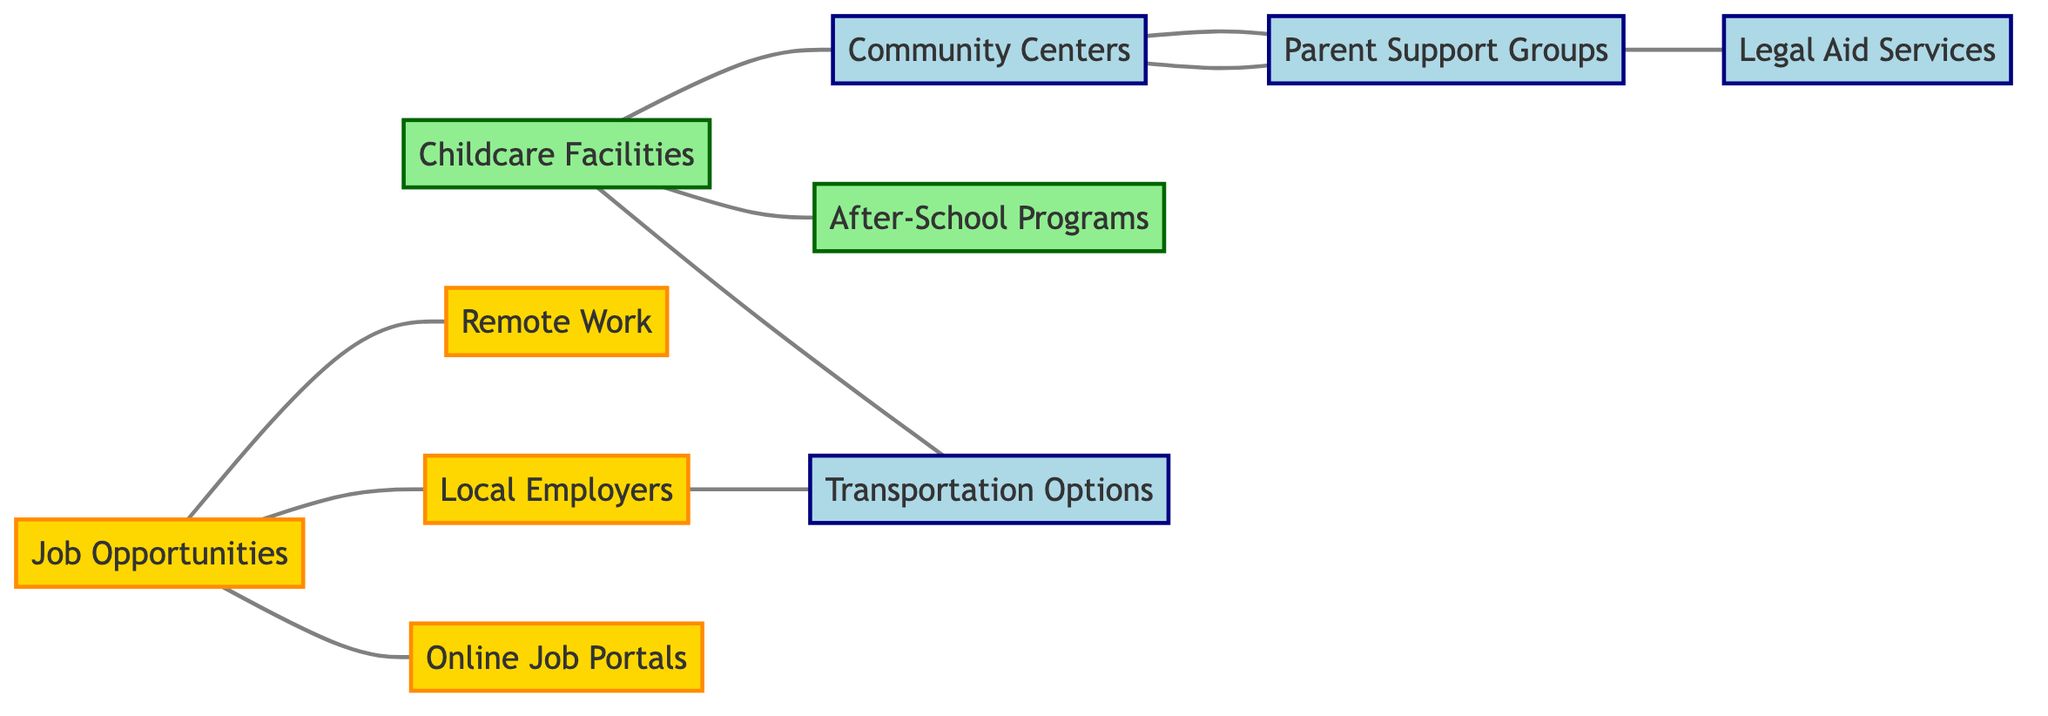What is the total number of nodes in the diagram? The diagram lists 10 different entities, each represented as a node, so we count all the distinct labels: Job Opportunities, Local Employers, Remote Work, Childcare Facilities, Community Centers, After-School Programs, Parent Support Groups, Legal Aid Services, Online Job Portals, and Transportation Options.
Answer: 10 Which nodes are connected directly to "Childcare Facilities"? "Childcare Facilities" connects directly to two other nodes: "Community Centers" and "After-School Programs". By reviewing the edges, we can see which nodes are linked to "Childcare Facilities".
Answer: Community Centers, After-School Programs How many edges are there in total? The diagram shows 10 connections (or edges) between nodes. Each edge represents a direct relationship between two nodes, and counting them gives us the total.
Answer: 10 Which node has a connection to both "Legal Aid Services" and "Parent Support Groups"? The node "Parent Support Groups" is connected to "Community Centers" and "Legal Aid Services". To confirm, we review the connections to see which nodes link to both.
Answer: Parent Support Groups What are the job types that can be connected through "Transportation Options"? "Transportation Options" is connected to "Local Employers" and "Childcare Facilities". Thus, the job types can be inferred as those potentially requiring travel to these nodes.
Answer: Local Employers, Childcare Facilities How many nodes related to jobs connect to "Online Job Portals"? The node "Online Job Portals" connects only to "Job Opportunities". By checking the edges, we see there is a direct link to just one node, making it straightforward to count.
Answer: 1 Which node type supports "After-School Programs"? "After-School Programs" is supported by "Childcare Facilities" because it's directly connected to it. We analyze to find links that qualify as supportive connections.
Answer: Childcare Facilities Is there a direct connection between "Remote Work" and any "Parent Support Groups"? There is no direct edge connecting "Remote Work" to "Parent Support Groups" in the diagram. We inspect the edges to verify the connection points between all nodes.
Answer: No 